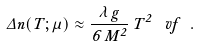<formula> <loc_0><loc_0><loc_500><loc_500>\Delta n ( T ; \mu ) \approx \frac { \lambda \, g } { 6 \, M ^ { 2 } } \, T ^ { 2 } \, \dot { \ } v f \ .</formula> 